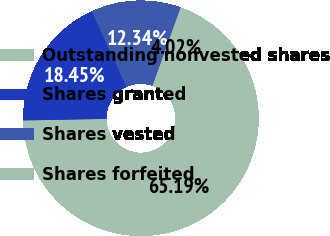Convert chart to OTSL. <chart><loc_0><loc_0><loc_500><loc_500><pie_chart><fcel>Outstanding nonvested shares<fcel>Shares granted<fcel>Shares vested<fcel>Shares forfeited<nl><fcel>65.19%<fcel>18.45%<fcel>12.34%<fcel>4.02%<nl></chart> 